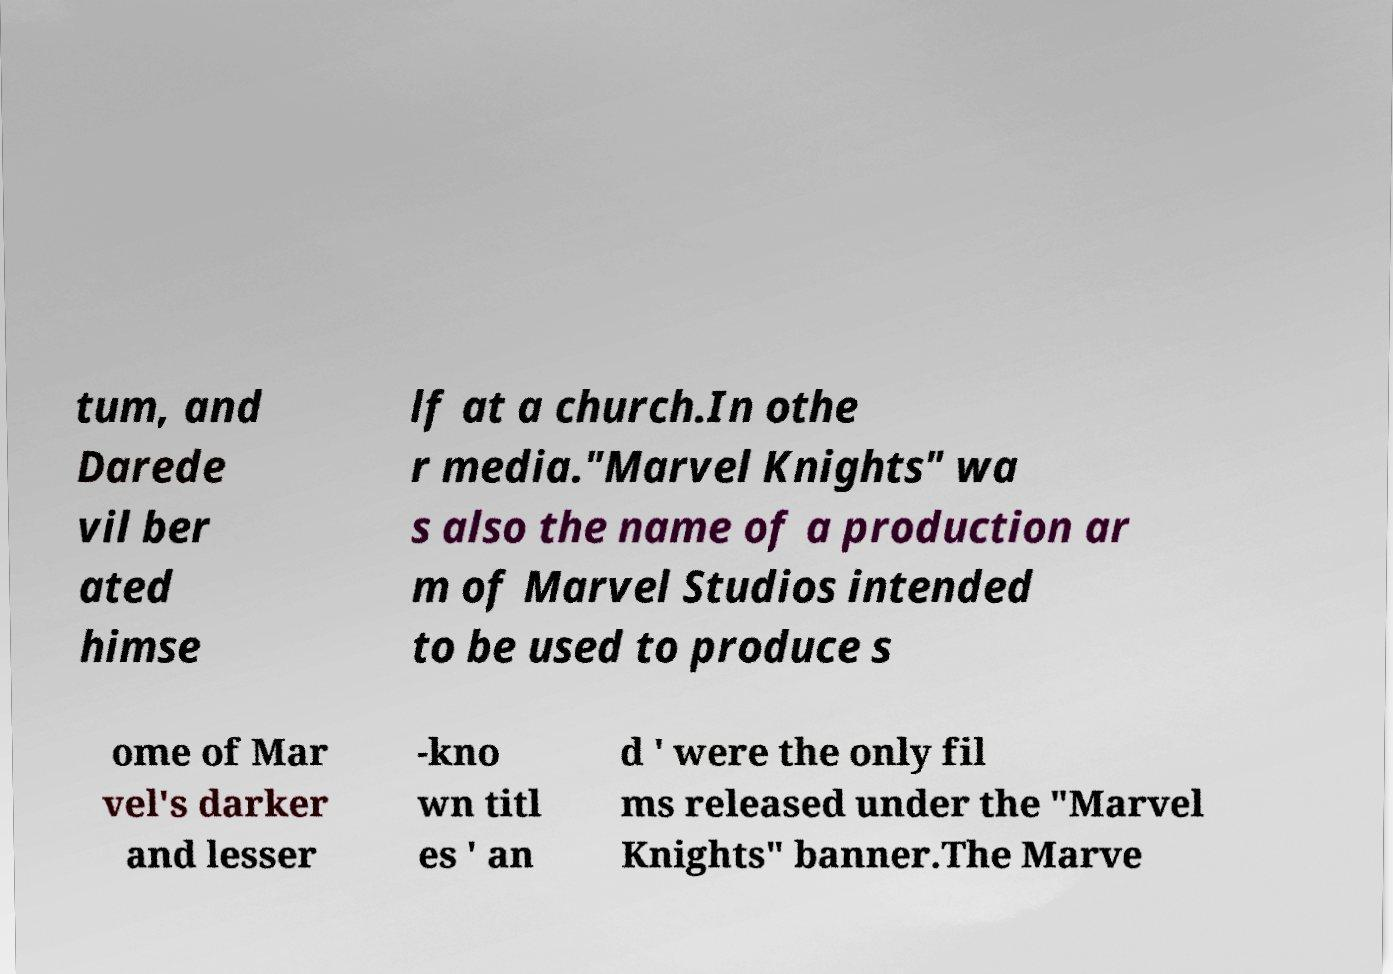For documentation purposes, I need the text within this image transcribed. Could you provide that? tum, and Darede vil ber ated himse lf at a church.In othe r media."Marvel Knights" wa s also the name of a production ar m of Marvel Studios intended to be used to produce s ome of Mar vel's darker and lesser -kno wn titl es ' an d ' were the only fil ms released under the "Marvel Knights" banner.The Marve 